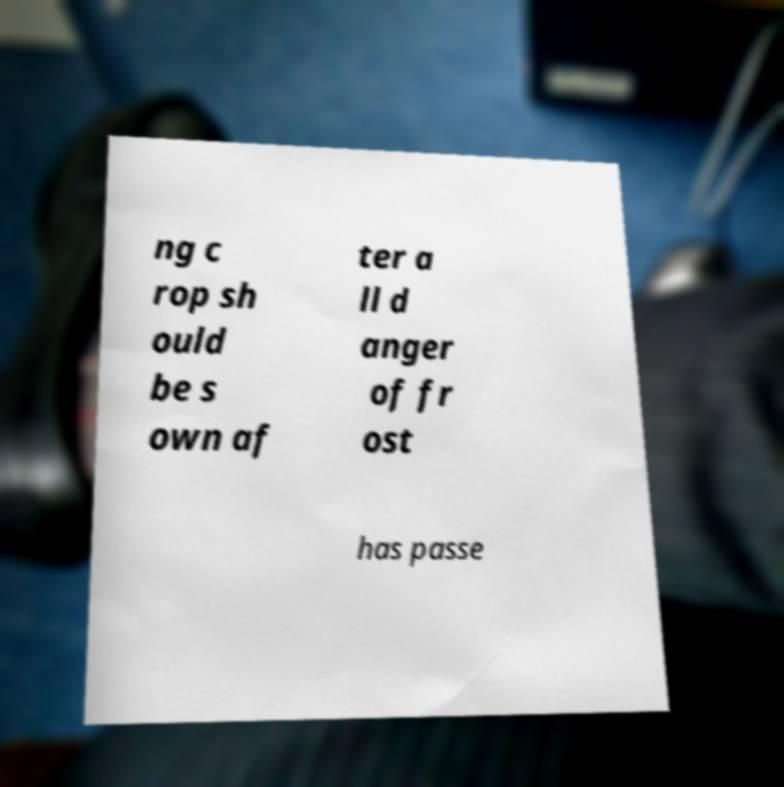Could you assist in decoding the text presented in this image and type it out clearly? ng c rop sh ould be s own af ter a ll d anger of fr ost has passe 